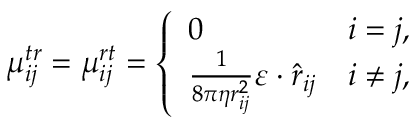Convert formula to latex. <formula><loc_0><loc_0><loc_500><loc_500>\mu _ { i j } ^ { t r } = \mu _ { i j } ^ { r t } = \left \{ \begin{array} { l l } { 0 } & { i = j , } \\ { \frac { 1 } { 8 \pi \eta r _ { i j } ^ { 2 } } \varepsilon \cdot \hat { r } _ { i j } } & { i \neq j , } \end{array}</formula> 